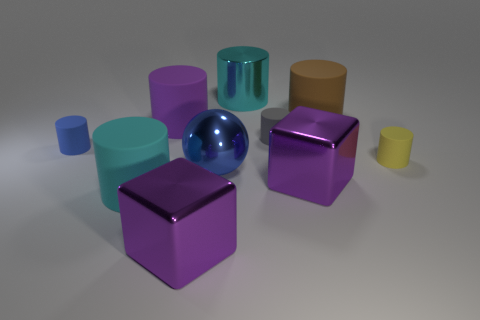Subtract all cyan matte cylinders. How many cylinders are left? 6 Subtract all brown cylinders. How many cylinders are left? 6 Subtract all gray cylinders. Subtract all brown spheres. How many cylinders are left? 6 Subtract all spheres. How many objects are left? 9 Add 2 brown matte things. How many brown matte things are left? 3 Add 6 large gray rubber cylinders. How many large gray rubber cylinders exist? 6 Subtract 0 red cylinders. How many objects are left? 10 Subtract all big cyan shiny things. Subtract all large blue spheres. How many objects are left? 8 